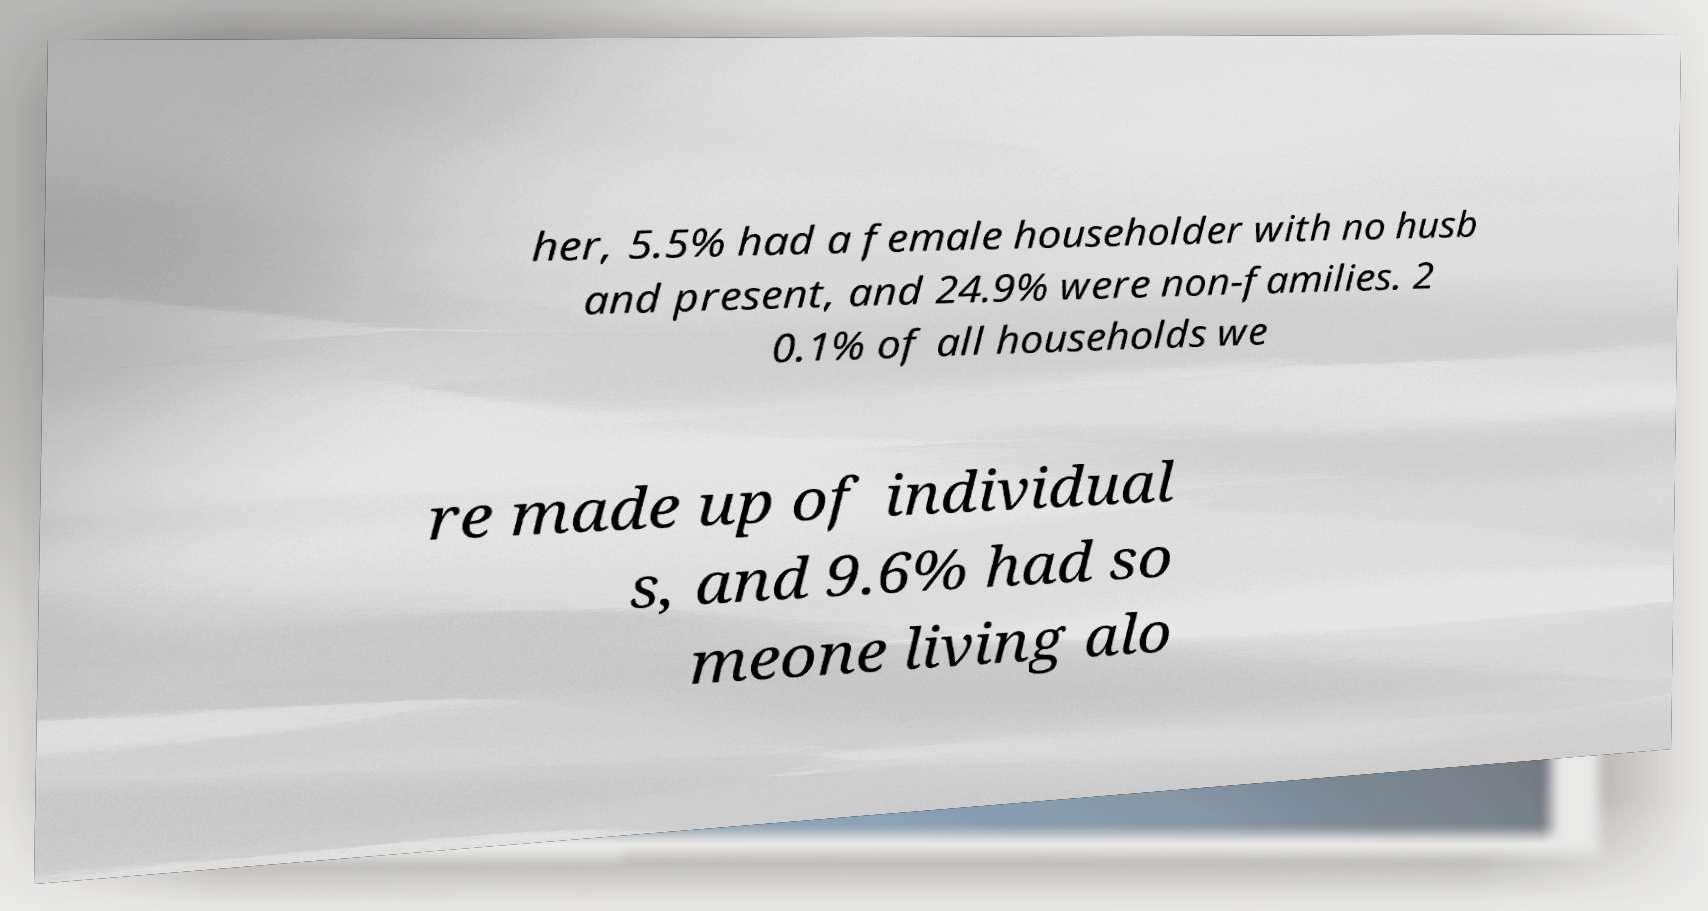I need the written content from this picture converted into text. Can you do that? her, 5.5% had a female householder with no husb and present, and 24.9% were non-families. 2 0.1% of all households we re made up of individual s, and 9.6% had so meone living alo 